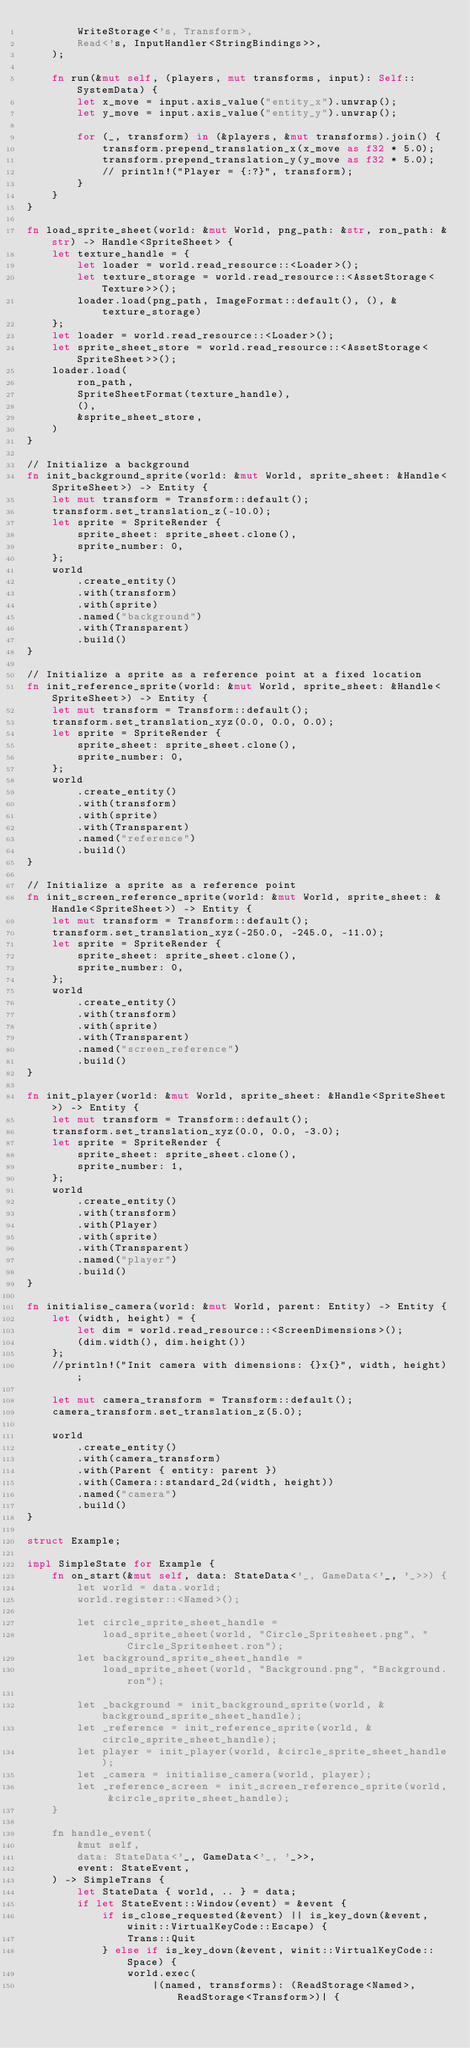<code> <loc_0><loc_0><loc_500><loc_500><_Rust_>        WriteStorage<'s, Transform>,
        Read<'s, InputHandler<StringBindings>>,
    );

    fn run(&mut self, (players, mut transforms, input): Self::SystemData) {
        let x_move = input.axis_value("entity_x").unwrap();
        let y_move = input.axis_value("entity_y").unwrap();

        for (_, transform) in (&players, &mut transforms).join() {
            transform.prepend_translation_x(x_move as f32 * 5.0);
            transform.prepend_translation_y(y_move as f32 * 5.0);
            // println!("Player = {:?}", transform);
        }
    }
}

fn load_sprite_sheet(world: &mut World, png_path: &str, ron_path: &str) -> Handle<SpriteSheet> {
    let texture_handle = {
        let loader = world.read_resource::<Loader>();
        let texture_storage = world.read_resource::<AssetStorage<Texture>>();
        loader.load(png_path, ImageFormat::default(), (), &texture_storage)
    };
    let loader = world.read_resource::<Loader>();
    let sprite_sheet_store = world.read_resource::<AssetStorage<SpriteSheet>>();
    loader.load(
        ron_path,
        SpriteSheetFormat(texture_handle),
        (),
        &sprite_sheet_store,
    )
}

// Initialize a background
fn init_background_sprite(world: &mut World, sprite_sheet: &Handle<SpriteSheet>) -> Entity {
    let mut transform = Transform::default();
    transform.set_translation_z(-10.0);
    let sprite = SpriteRender {
        sprite_sheet: sprite_sheet.clone(),
        sprite_number: 0,
    };
    world
        .create_entity()
        .with(transform)
        .with(sprite)
        .named("background")
        .with(Transparent)
        .build()
}

// Initialize a sprite as a reference point at a fixed location
fn init_reference_sprite(world: &mut World, sprite_sheet: &Handle<SpriteSheet>) -> Entity {
    let mut transform = Transform::default();
    transform.set_translation_xyz(0.0, 0.0, 0.0);
    let sprite = SpriteRender {
        sprite_sheet: sprite_sheet.clone(),
        sprite_number: 0,
    };
    world
        .create_entity()
        .with(transform)
        .with(sprite)
        .with(Transparent)
        .named("reference")
        .build()
}

// Initialize a sprite as a reference point
fn init_screen_reference_sprite(world: &mut World, sprite_sheet: &Handle<SpriteSheet>) -> Entity {
    let mut transform = Transform::default();
    transform.set_translation_xyz(-250.0, -245.0, -11.0);
    let sprite = SpriteRender {
        sprite_sheet: sprite_sheet.clone(),
        sprite_number: 0,
    };
    world
        .create_entity()
        .with(transform)
        .with(sprite)
        .with(Transparent)
        .named("screen_reference")
        .build()
}

fn init_player(world: &mut World, sprite_sheet: &Handle<SpriteSheet>) -> Entity {
    let mut transform = Transform::default();
    transform.set_translation_xyz(0.0, 0.0, -3.0);
    let sprite = SpriteRender {
        sprite_sheet: sprite_sheet.clone(),
        sprite_number: 1,
    };
    world
        .create_entity()
        .with(transform)
        .with(Player)
        .with(sprite)
        .with(Transparent)
        .named("player")
        .build()
}

fn initialise_camera(world: &mut World, parent: Entity) -> Entity {
    let (width, height) = {
        let dim = world.read_resource::<ScreenDimensions>();
        (dim.width(), dim.height())
    };
    //println!("Init camera with dimensions: {}x{}", width, height);

    let mut camera_transform = Transform::default();
    camera_transform.set_translation_z(5.0);

    world
        .create_entity()
        .with(camera_transform)
        .with(Parent { entity: parent })
        .with(Camera::standard_2d(width, height))
        .named("camera")
        .build()
}

struct Example;

impl SimpleState for Example {
    fn on_start(&mut self, data: StateData<'_, GameData<'_, '_>>) {
        let world = data.world;
        world.register::<Named>();

        let circle_sprite_sheet_handle =
            load_sprite_sheet(world, "Circle_Spritesheet.png", "Circle_Spritesheet.ron");
        let background_sprite_sheet_handle =
            load_sprite_sheet(world, "Background.png", "Background.ron");

        let _background = init_background_sprite(world, &background_sprite_sheet_handle);
        let _reference = init_reference_sprite(world, &circle_sprite_sheet_handle);
        let player = init_player(world, &circle_sprite_sheet_handle);
        let _camera = initialise_camera(world, player);
        let _reference_screen = init_screen_reference_sprite(world, &circle_sprite_sheet_handle);
    }

    fn handle_event(
        &mut self,
        data: StateData<'_, GameData<'_, '_>>,
        event: StateEvent,
    ) -> SimpleTrans {
        let StateData { world, .. } = data;
        if let StateEvent::Window(event) = &event {
            if is_close_requested(&event) || is_key_down(&event, winit::VirtualKeyCode::Escape) {
                Trans::Quit
            } else if is_key_down(&event, winit::VirtualKeyCode::Space) {
                world.exec(
                    |(named, transforms): (ReadStorage<Named>, ReadStorage<Transform>)| {</code> 